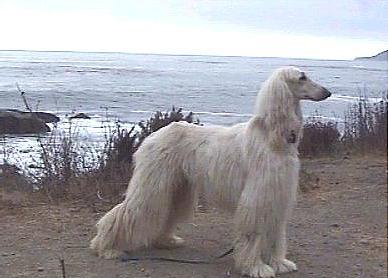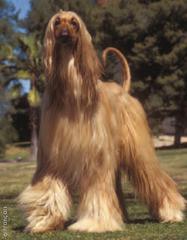The first image is the image on the left, the second image is the image on the right. For the images shown, is this caption "One image shows a light-colored afghan hound gazing rightward into the distance." true? Answer yes or no. Yes. The first image is the image on the left, the second image is the image on the right. Evaluate the accuracy of this statement regarding the images: "There is an Afghan dog being held on a leash.". Is it true? Answer yes or no. No. 